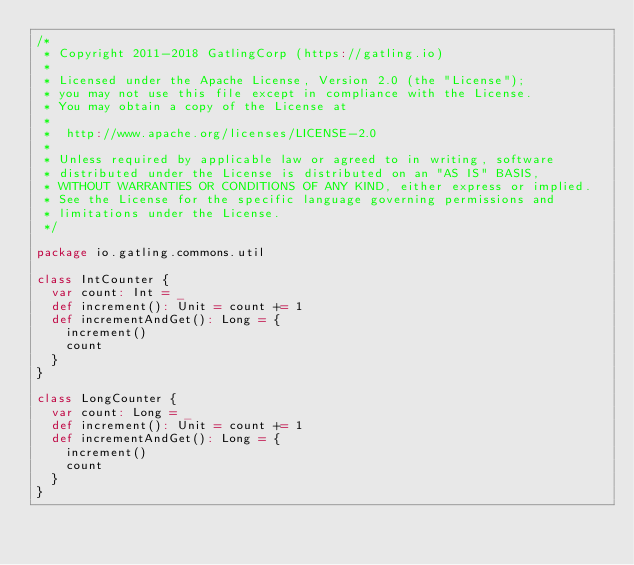<code> <loc_0><loc_0><loc_500><loc_500><_Scala_>/*
 * Copyright 2011-2018 GatlingCorp (https://gatling.io)
 *
 * Licensed under the Apache License, Version 2.0 (the "License");
 * you may not use this file except in compliance with the License.
 * You may obtain a copy of the License at
 *
 *  http://www.apache.org/licenses/LICENSE-2.0
 *
 * Unless required by applicable law or agreed to in writing, software
 * distributed under the License is distributed on an "AS IS" BASIS,
 * WITHOUT WARRANTIES OR CONDITIONS OF ANY KIND, either express or implied.
 * See the License for the specific language governing permissions and
 * limitations under the License.
 */

package io.gatling.commons.util

class IntCounter {
  var count: Int = _
  def increment(): Unit = count += 1
  def incrementAndGet(): Long = {
    increment()
    count
  }
}

class LongCounter {
  var count: Long = _
  def increment(): Unit = count += 1
  def incrementAndGet(): Long = {
    increment()
    count
  }
}
</code> 